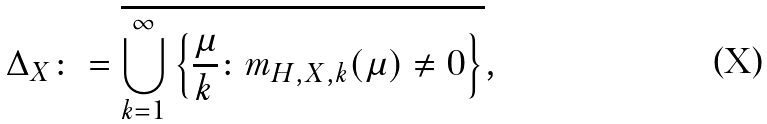Convert formula to latex. <formula><loc_0><loc_0><loc_500><loc_500>\Delta _ { X } \colon = \overline { \bigcup _ { k = 1 } ^ { \infty } \left \{ \frac { \mu } { k } \colon m _ { H , X , k } ( \mu ) \neq 0 \right \} } ,</formula> 